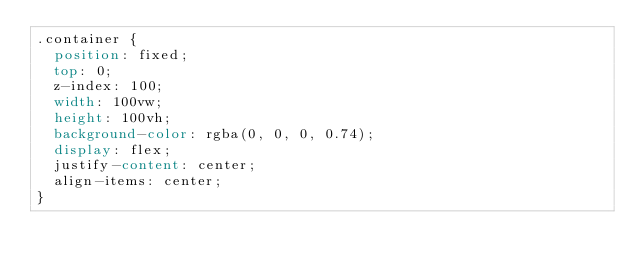Convert code to text. <code><loc_0><loc_0><loc_500><loc_500><_CSS_>.container {
  position: fixed;
  top: 0;
  z-index: 100;
  width: 100vw;
  height: 100vh;
  background-color: rgba(0, 0, 0, 0.74);
  display: flex;
  justify-content: center;
  align-items: center;
}
</code> 